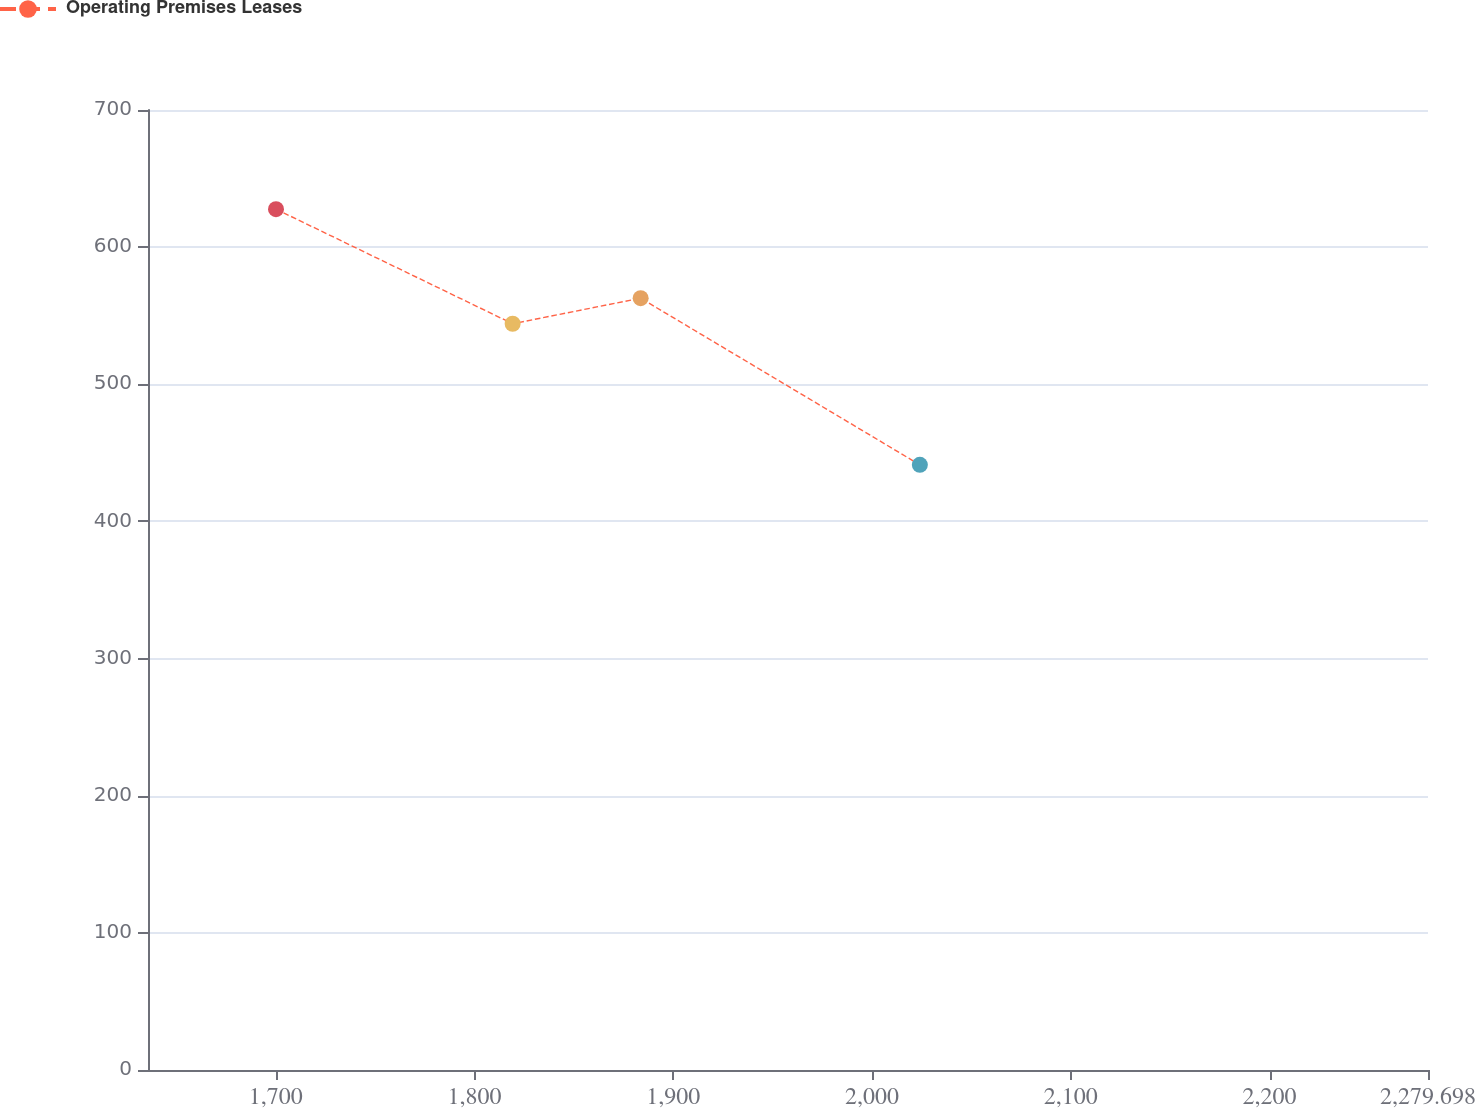Convert chart to OTSL. <chart><loc_0><loc_0><loc_500><loc_500><line_chart><ecel><fcel>Operating Premises Leases<nl><fcel>1700.08<fcel>627.68<nl><fcel>1819.15<fcel>544.15<nl><fcel>1883.55<fcel>562.79<nl><fcel>2024.03<fcel>441.27<nl><fcel>2344.1<fcel>459.91<nl></chart> 